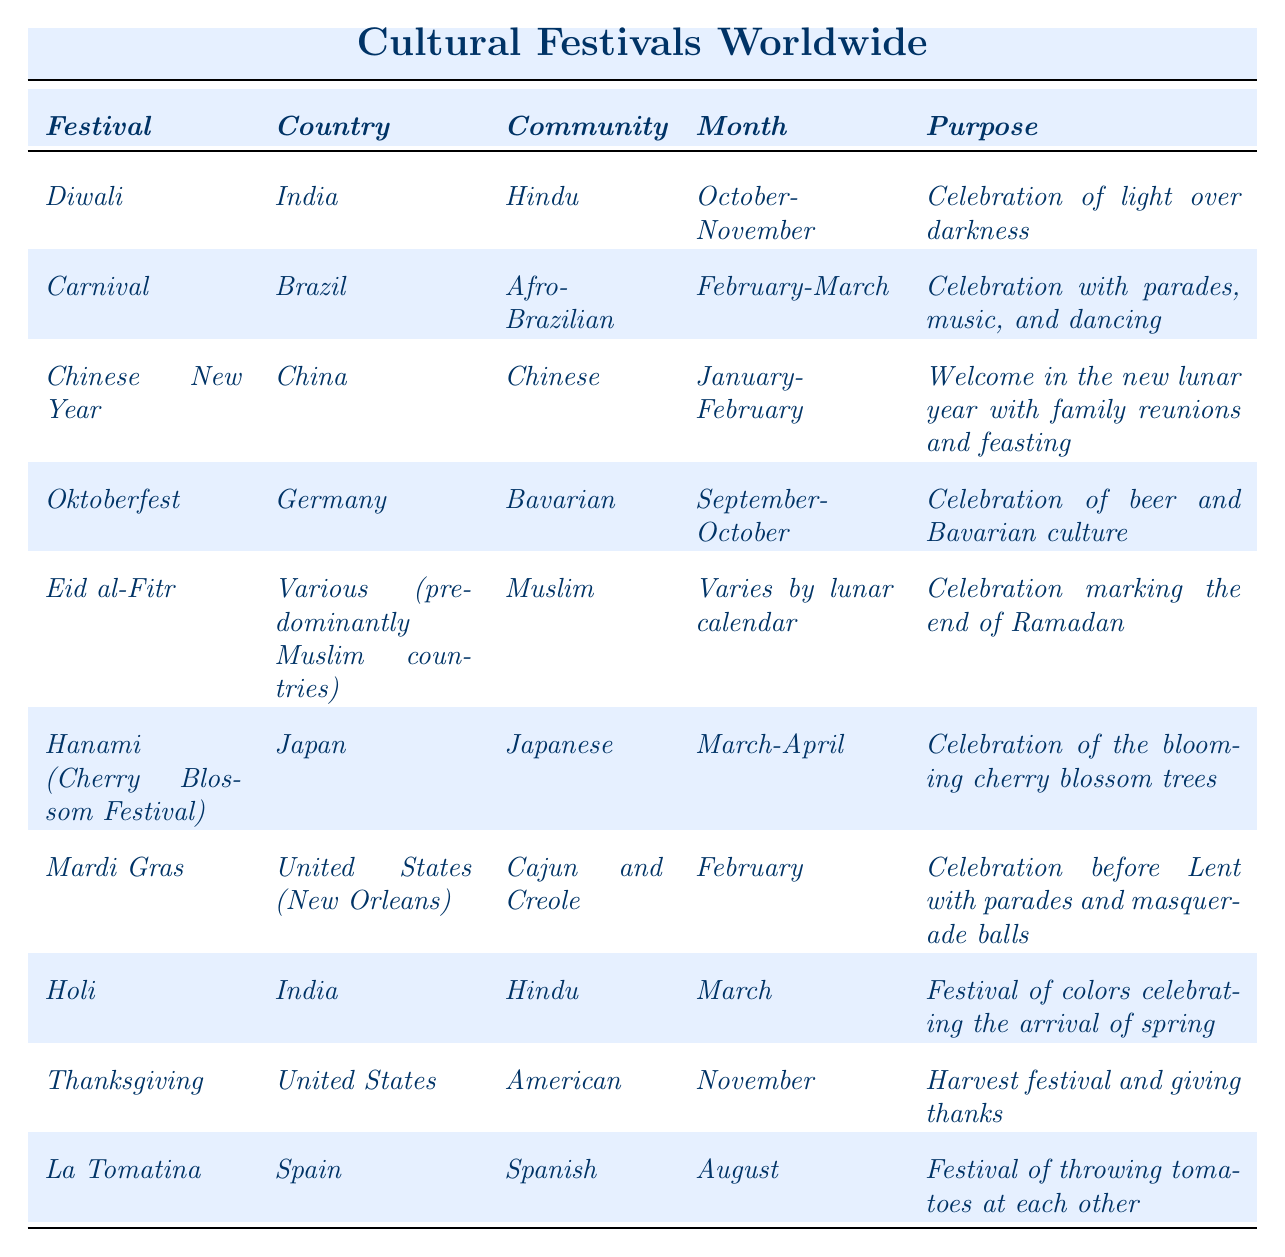What is the purpose of the Holi festival? The table states that the purpose of Holi is "Festival of colors celebrating the arrival of spring."
Answer: Festival of colors celebrating the arrival of spring In which month is the Carnival festival celebrated in Brazil? According to the table, the Carnival festival is celebrated in February-March.
Answer: February-March How many festivals are celebrated by the Hindu community according to the table? The table lists two festivals for the Hindu community: Diwali and Holi. Therefore, the count is 2.
Answer: 2 Does the table indicate that Thanksgiving is celebrated in more than one country? The table specifies that Thanksgiving is only associated with the United States, indicating that it is not celebrated in more than one country.
Answer: No Which festival is celebrated in both March and October? The table shows that Holi is celebrated in March, and Diwali is celebrated in October-November. No single festival is listed in both months.
Answer: None What is the common feature of the Chinese New Year and Eid al-Fitr in terms of their celebration? Both festivals involve significant family gatherings: Chinese New Year is about family reunions, and Eid al-Fitr marks the end of Ramadan with communal celebrations and gatherings.
Answer: Family gatherings Which festival in the table is associated with a specific country and community but does not fall into the typical month categories due to its varying date? The festival Eid al-Fitr is listed as having a varying date according to the lunar calendar, making it unique in that context.
Answer: Eid al-Fitr How does the purpose of La Tomatina differ from the purposes of the cultural festivities related to religious celebrations in the table? La Tomatina is focused on a playful activity of throwing tomatoes, while the religious festivals such as Diwali and Eid al-Fitr emphasize spiritual and family significance.
Answer: It focuses on playful activity rather than spirituality List the festivals that are primarily celebrated in the month of February. The table indicates that both Carnival and Mardi Gras are celebrated in February, making them the only festivals in that month.
Answer: Carnival, Mardi Gras What is the single largest month range that has multiple festivals according to the table? The month range of October-November includes Diwali and Thanksgiving, thus covering multiple festivals within that span.
Answer: October-November 